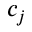Convert formula to latex. <formula><loc_0><loc_0><loc_500><loc_500>c _ { j }</formula> 